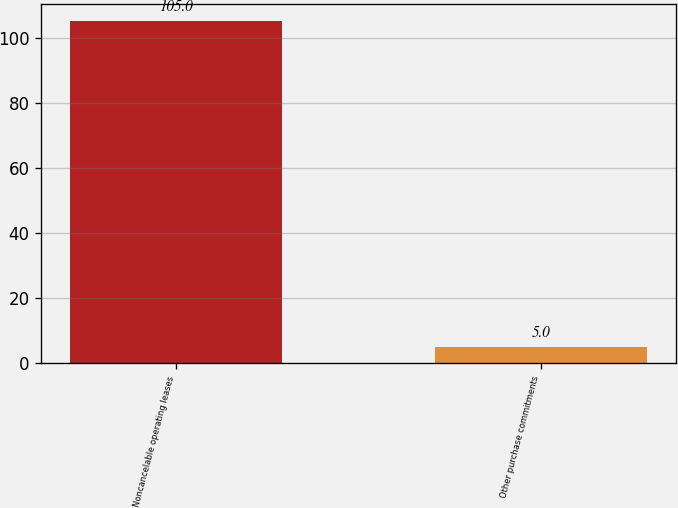<chart> <loc_0><loc_0><loc_500><loc_500><bar_chart><fcel>Noncancelable operating leases<fcel>Other purchase commitments<nl><fcel>105<fcel>5<nl></chart> 